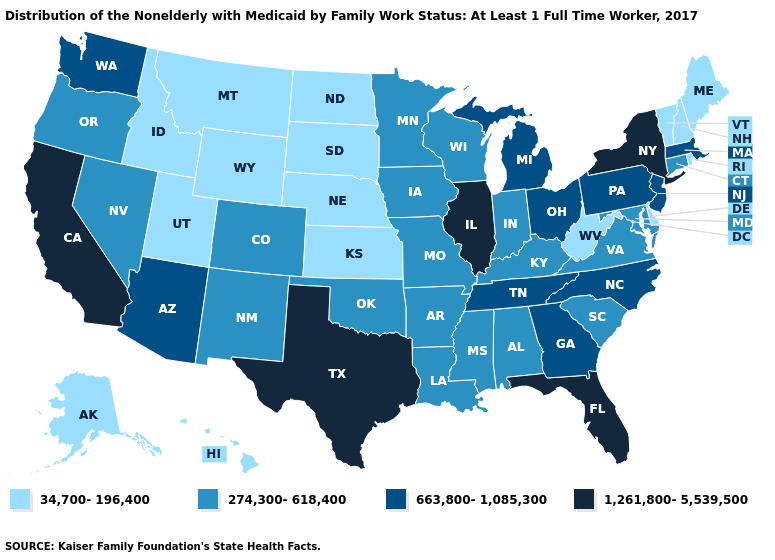Does South Dakota have the same value as Rhode Island?
Concise answer only. Yes. Name the states that have a value in the range 274,300-618,400?
Concise answer only. Alabama, Arkansas, Colorado, Connecticut, Indiana, Iowa, Kentucky, Louisiana, Maryland, Minnesota, Mississippi, Missouri, Nevada, New Mexico, Oklahoma, Oregon, South Carolina, Virginia, Wisconsin. Does Wisconsin have the lowest value in the USA?
Keep it brief. No. What is the value of Colorado?
Give a very brief answer. 274,300-618,400. What is the highest value in the South ?
Write a very short answer. 1,261,800-5,539,500. Which states have the lowest value in the Northeast?
Keep it brief. Maine, New Hampshire, Rhode Island, Vermont. Among the states that border Tennessee , which have the lowest value?
Give a very brief answer. Alabama, Arkansas, Kentucky, Mississippi, Missouri, Virginia. Name the states that have a value in the range 274,300-618,400?
Be succinct. Alabama, Arkansas, Colorado, Connecticut, Indiana, Iowa, Kentucky, Louisiana, Maryland, Minnesota, Mississippi, Missouri, Nevada, New Mexico, Oklahoma, Oregon, South Carolina, Virginia, Wisconsin. Which states have the lowest value in the Northeast?
Be succinct. Maine, New Hampshire, Rhode Island, Vermont. What is the lowest value in the USA?
Give a very brief answer. 34,700-196,400. What is the highest value in states that border Minnesota?
Keep it brief. 274,300-618,400. Does North Dakota have the highest value in the MidWest?
Keep it brief. No. Does the map have missing data?
Concise answer only. No. What is the lowest value in the USA?
Give a very brief answer. 34,700-196,400. What is the lowest value in the USA?
Answer briefly. 34,700-196,400. 